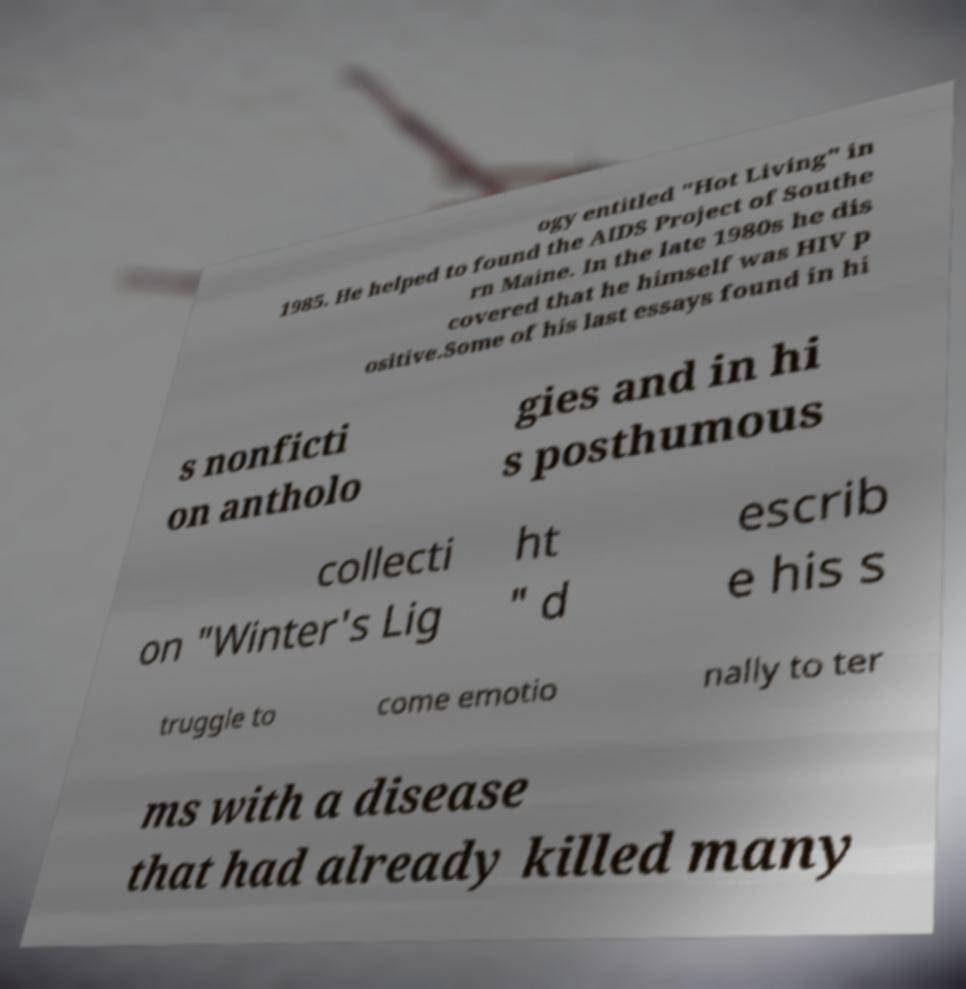I need the written content from this picture converted into text. Can you do that? ogy entitled "Hot Living" in 1985. He helped to found the AIDS Project of Southe rn Maine. In the late 1980s he dis covered that he himself was HIV p ositive.Some of his last essays found in hi s nonficti on antholo gies and in hi s posthumous collecti on "Winter's Lig ht " d escrib e his s truggle to come emotio nally to ter ms with a disease that had already killed many 